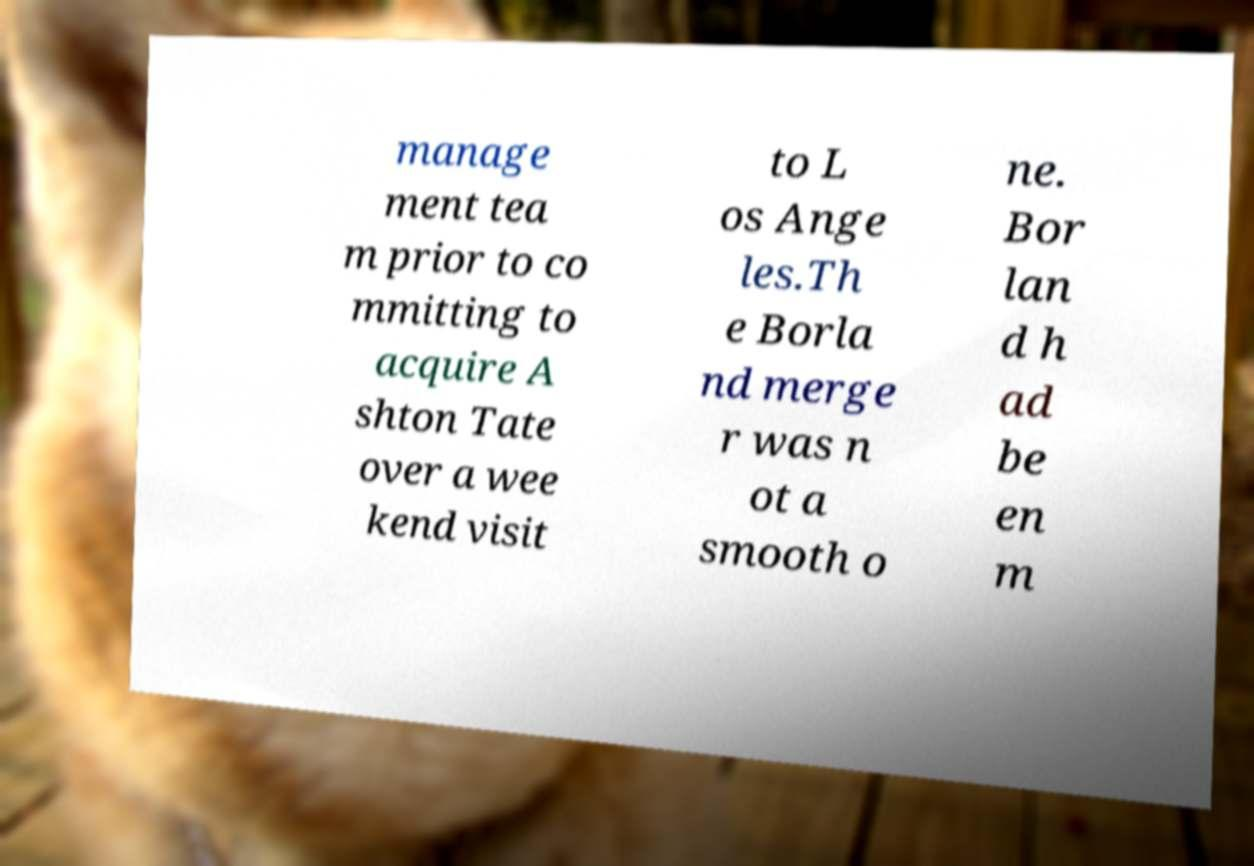I need the written content from this picture converted into text. Can you do that? manage ment tea m prior to co mmitting to acquire A shton Tate over a wee kend visit to L os Ange les.Th e Borla nd merge r was n ot a smooth o ne. Bor lan d h ad be en m 